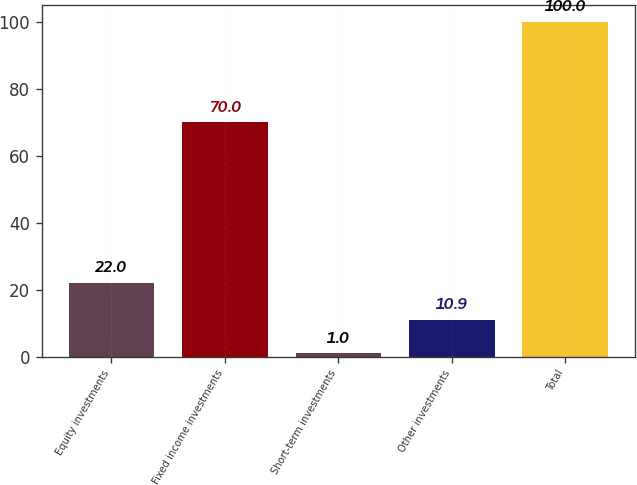Convert chart. <chart><loc_0><loc_0><loc_500><loc_500><bar_chart><fcel>Equity investments<fcel>Fixed income investments<fcel>Short-term investments<fcel>Other investments<fcel>Total<nl><fcel>22<fcel>70<fcel>1<fcel>10.9<fcel>100<nl></chart> 